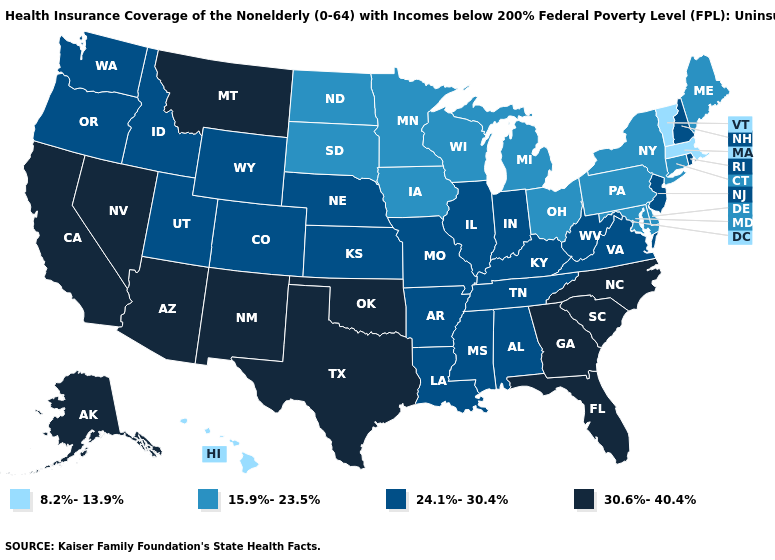What is the highest value in the USA?
Give a very brief answer. 30.6%-40.4%. Name the states that have a value in the range 15.9%-23.5%?
Write a very short answer. Connecticut, Delaware, Iowa, Maine, Maryland, Michigan, Minnesota, New York, North Dakota, Ohio, Pennsylvania, South Dakota, Wisconsin. What is the lowest value in the USA?
Keep it brief. 8.2%-13.9%. Is the legend a continuous bar?
Write a very short answer. No. Does the map have missing data?
Keep it brief. No. Does the map have missing data?
Write a very short answer. No. Name the states that have a value in the range 30.6%-40.4%?
Keep it brief. Alaska, Arizona, California, Florida, Georgia, Montana, Nevada, New Mexico, North Carolina, Oklahoma, South Carolina, Texas. Is the legend a continuous bar?
Give a very brief answer. No. Which states have the highest value in the USA?
Give a very brief answer. Alaska, Arizona, California, Florida, Georgia, Montana, Nevada, New Mexico, North Carolina, Oklahoma, South Carolina, Texas. What is the lowest value in states that border Texas?
Give a very brief answer. 24.1%-30.4%. Name the states that have a value in the range 24.1%-30.4%?
Concise answer only. Alabama, Arkansas, Colorado, Idaho, Illinois, Indiana, Kansas, Kentucky, Louisiana, Mississippi, Missouri, Nebraska, New Hampshire, New Jersey, Oregon, Rhode Island, Tennessee, Utah, Virginia, Washington, West Virginia, Wyoming. Name the states that have a value in the range 15.9%-23.5%?
Short answer required. Connecticut, Delaware, Iowa, Maine, Maryland, Michigan, Minnesota, New York, North Dakota, Ohio, Pennsylvania, South Dakota, Wisconsin. Does Nebraska have a lower value than Montana?
Answer briefly. Yes. What is the value of Tennessee?
Keep it brief. 24.1%-30.4%. 